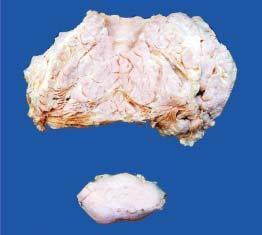what shows a separate encapsulated gelatinous mass?
Answer the question using a single word or phrase. Lower part of the image 